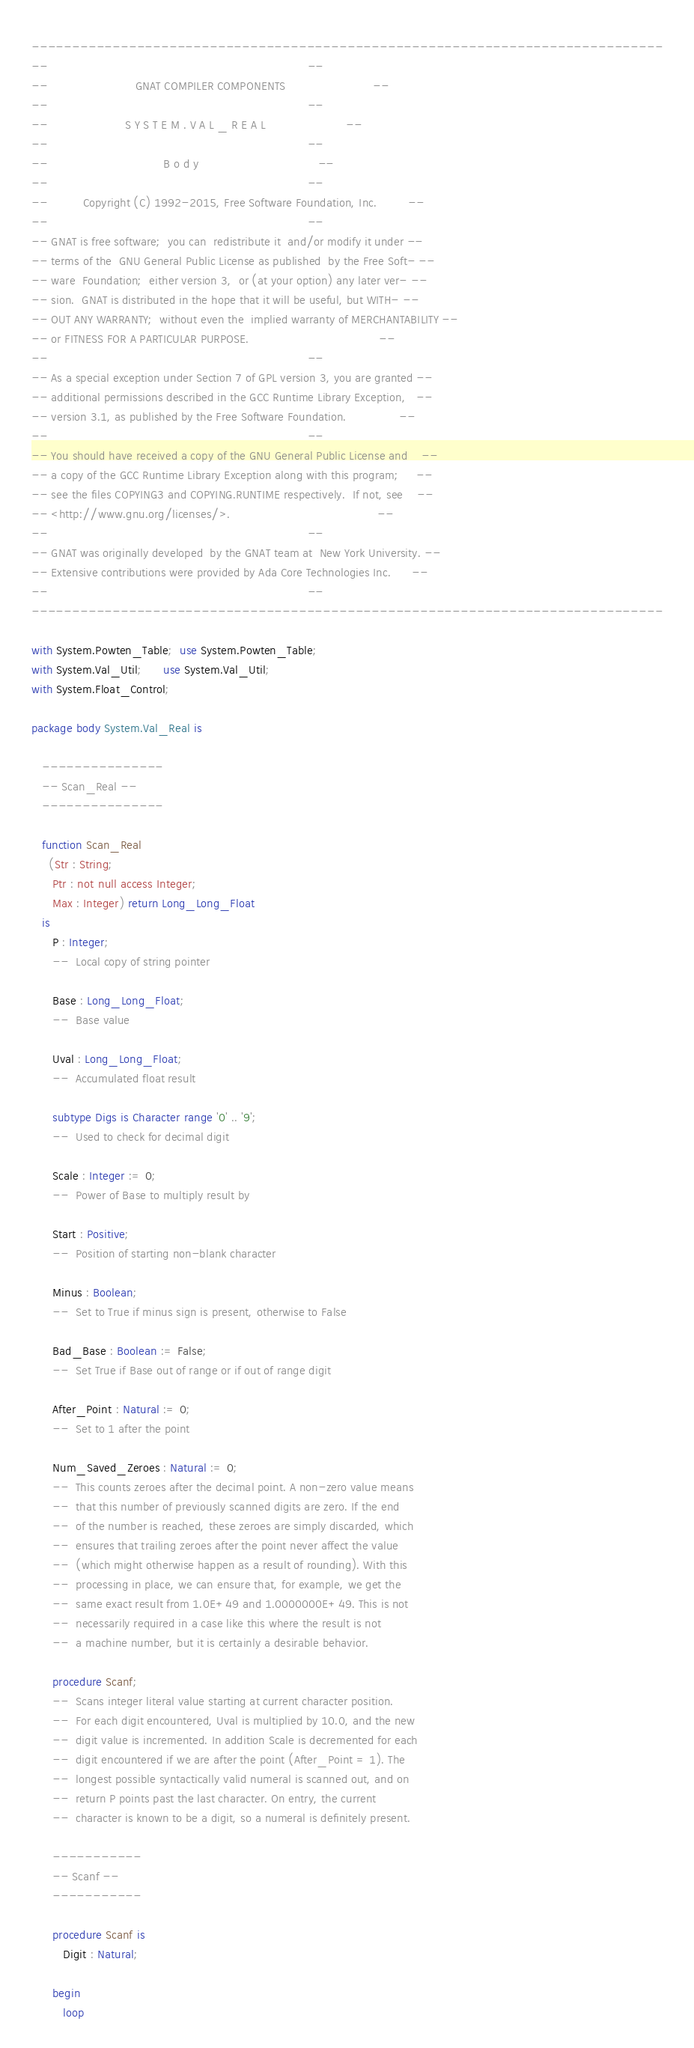Convert code to text. <code><loc_0><loc_0><loc_500><loc_500><_Ada_>------------------------------------------------------------------------------
--                                                                          --
--                         GNAT COMPILER COMPONENTS                         --
--                                                                          --
--                      S Y S T E M . V A L _ R E A L                       --
--                                                                          --
--                                 B o d y                                  --
--                                                                          --
--          Copyright (C) 1992-2015, Free Software Foundation, Inc.         --
--                                                                          --
-- GNAT is free software;  you can  redistribute it  and/or modify it under --
-- terms of the  GNU General Public License as published  by the Free Soft- --
-- ware  Foundation;  either version 3,  or (at your option) any later ver- --
-- sion.  GNAT is distributed in the hope that it will be useful, but WITH- --
-- OUT ANY WARRANTY;  without even the  implied warranty of MERCHANTABILITY --
-- or FITNESS FOR A PARTICULAR PURPOSE.                                     --
--                                                                          --
-- As a special exception under Section 7 of GPL version 3, you are granted --
-- additional permissions described in the GCC Runtime Library Exception,   --
-- version 3.1, as published by the Free Software Foundation.               --
--                                                                          --
-- You should have received a copy of the GNU General Public License and    --
-- a copy of the GCC Runtime Library Exception along with this program;     --
-- see the files COPYING3 and COPYING.RUNTIME respectively.  If not, see    --
-- <http://www.gnu.org/licenses/>.                                          --
--                                                                          --
-- GNAT was originally developed  by the GNAT team at  New York University. --
-- Extensive contributions were provided by Ada Core Technologies Inc.      --
--                                                                          --
------------------------------------------------------------------------------

with System.Powten_Table;  use System.Powten_Table;
with System.Val_Util;      use System.Val_Util;
with System.Float_Control;

package body System.Val_Real is

   ---------------
   -- Scan_Real --
   ---------------

   function Scan_Real
     (Str : String;
      Ptr : not null access Integer;
      Max : Integer) return Long_Long_Float
   is
      P : Integer;
      --  Local copy of string pointer

      Base : Long_Long_Float;
      --  Base value

      Uval : Long_Long_Float;
      --  Accumulated float result

      subtype Digs is Character range '0' .. '9';
      --  Used to check for decimal digit

      Scale : Integer := 0;
      --  Power of Base to multiply result by

      Start : Positive;
      --  Position of starting non-blank character

      Minus : Boolean;
      --  Set to True if minus sign is present, otherwise to False

      Bad_Base : Boolean := False;
      --  Set True if Base out of range or if out of range digit

      After_Point : Natural := 0;
      --  Set to 1 after the point

      Num_Saved_Zeroes : Natural := 0;
      --  This counts zeroes after the decimal point. A non-zero value means
      --  that this number of previously scanned digits are zero. If the end
      --  of the number is reached, these zeroes are simply discarded, which
      --  ensures that trailing zeroes after the point never affect the value
      --  (which might otherwise happen as a result of rounding). With this
      --  processing in place, we can ensure that, for example, we get the
      --  same exact result from 1.0E+49 and 1.0000000E+49. This is not
      --  necessarily required in a case like this where the result is not
      --  a machine number, but it is certainly a desirable behavior.

      procedure Scanf;
      --  Scans integer literal value starting at current character position.
      --  For each digit encountered, Uval is multiplied by 10.0, and the new
      --  digit value is incremented. In addition Scale is decremented for each
      --  digit encountered if we are after the point (After_Point = 1). The
      --  longest possible syntactically valid numeral is scanned out, and on
      --  return P points past the last character. On entry, the current
      --  character is known to be a digit, so a numeral is definitely present.

      -----------
      -- Scanf --
      -----------

      procedure Scanf is
         Digit : Natural;

      begin
         loop</code> 